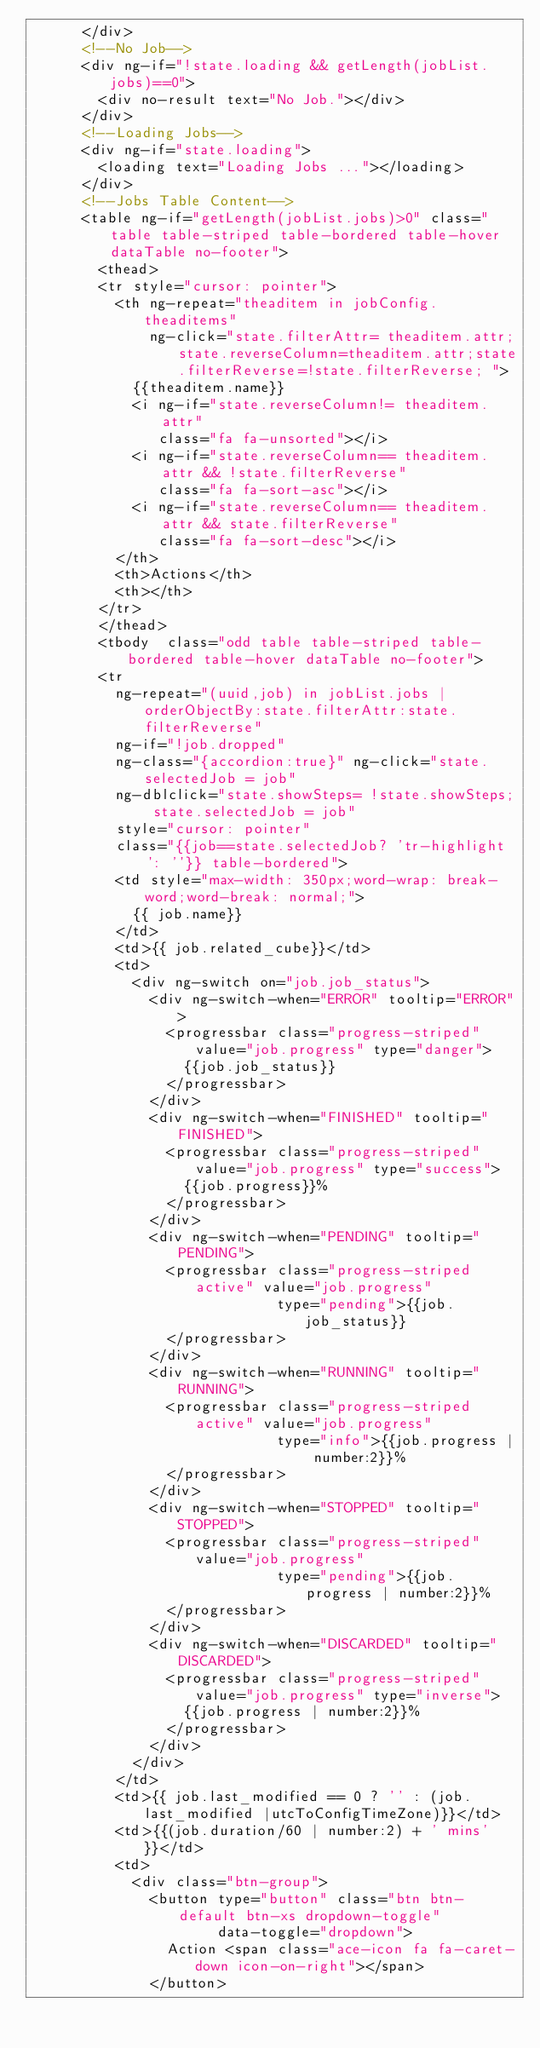Convert code to text. <code><loc_0><loc_0><loc_500><loc_500><_HTML_>      </div>
      <!--No Job-->
      <div ng-if="!state.loading && getLength(jobList.jobs)==0">
        <div no-result text="No Job."></div>
      </div>
      <!--Loading Jobs-->
      <div ng-if="state.loading">
        <loading text="Loading Jobs ..."></loading>
      </div>
      <!--Jobs Table Content-->
      <table ng-if="getLength(jobList.jobs)>0" class="table table-striped table-bordered table-hover dataTable no-footer">
        <thead>
        <tr style="cursor: pointer">
          <th ng-repeat="theaditem in jobConfig.theaditems"
              ng-click="state.filterAttr= theaditem.attr;state.reverseColumn=theaditem.attr;state.filterReverse=!state.filterReverse; ">
            {{theaditem.name}}
            <i ng-if="state.reverseColumn!= theaditem.attr"
               class="fa fa-unsorted"></i>
            <i ng-if="state.reverseColumn== theaditem.attr && !state.filterReverse"
               class="fa fa-sort-asc"></i>
            <i ng-if="state.reverseColumn== theaditem.attr && state.filterReverse"
               class="fa fa-sort-desc"></i>
          </th>
          <th>Actions</th>
          <th></th>
        </tr>
        </thead>
        <tbody  class="odd table table-striped table-bordered table-hover dataTable no-footer">
        <tr
          ng-repeat="(uuid,job) in jobList.jobs | orderObjectBy:state.filterAttr:state.filterReverse"
          ng-if="!job.dropped"
          ng-class="{accordion:true}" ng-click="state.selectedJob = job"
          ng-dblclick="state.showSteps= !state.showSteps; state.selectedJob = job"
          style="cursor: pointer"
          class="{{job==state.selectedJob? 'tr-highlight': ''}} table-bordered">
          <td style="max-width: 350px;word-wrap: break-word;word-break: normal;">
            {{ job.name}}
          </td>
          <td>{{ job.related_cube}}</td>
          <td>
            <div ng-switch on="job.job_status">
              <div ng-switch-when="ERROR" tooltip="ERROR">
                <progressbar class="progress-striped" value="job.progress" type="danger">
                  {{job.job_status}}
                </progressbar>
              </div>
              <div ng-switch-when="FINISHED" tooltip="FINISHED">
                <progressbar class="progress-striped" value="job.progress" type="success">
                  {{job.progress}}%
                </progressbar>
              </div>
              <div ng-switch-when="PENDING" tooltip="PENDING">
                <progressbar class="progress-striped active" value="job.progress"
                             type="pending">{{job.job_status}}
                </progressbar>
              </div>
              <div ng-switch-when="RUNNING" tooltip="RUNNING">
                <progressbar class="progress-striped active" value="job.progress"
                             type="info">{{job.progress | number:2}}%
                </progressbar>
              </div>
              <div ng-switch-when="STOPPED" tooltip="STOPPED">
                <progressbar class="progress-striped" value="job.progress"
                             type="pending">{{job.progress | number:2}}%
                </progressbar>
              </div>
              <div ng-switch-when="DISCARDED" tooltip="DISCARDED">
                <progressbar class="progress-striped" value="job.progress" type="inverse">
                  {{job.progress | number:2}}%
                </progressbar>
              </div>
            </div>
          </td>
          <td>{{ job.last_modified == 0 ? '' : (job.last_modified |utcToConfigTimeZone)}}</td>
          <td>{{(job.duration/60 | number:2) + ' mins'}}</td>
          <td>
            <div class="btn-group">
              <button type="button" class="btn btn-default btn-xs dropdown-toggle"
                      data-toggle="dropdown">
                Action <span class="ace-icon fa fa-caret-down icon-on-right"></span>
              </button></code> 